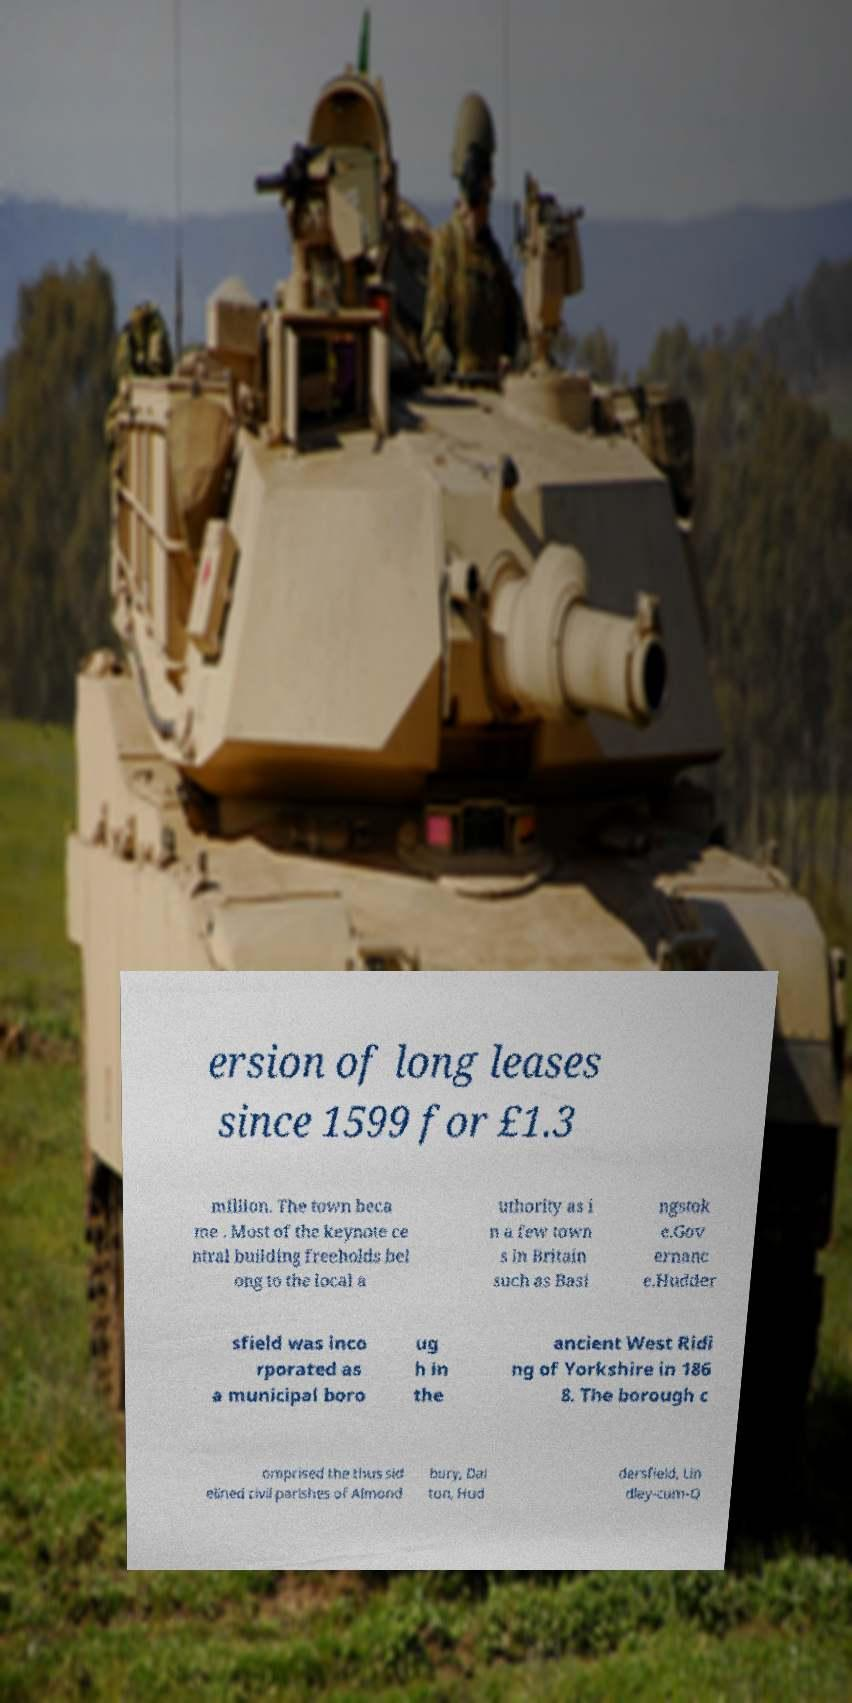Could you assist in decoding the text presented in this image and type it out clearly? ersion of long leases since 1599 for £1.3 million. The town beca me . Most of the keynote ce ntral building freeholds bel ong to the local a uthority as i n a few town s in Britain such as Basi ngstok e.Gov ernanc e.Hudder sfield was inco rporated as a municipal boro ug h in the ancient West Ridi ng of Yorkshire in 186 8. The borough c omprised the thus sid elined civil parishes of Almond bury, Dal ton, Hud dersfield, Lin dley-cum-Q 